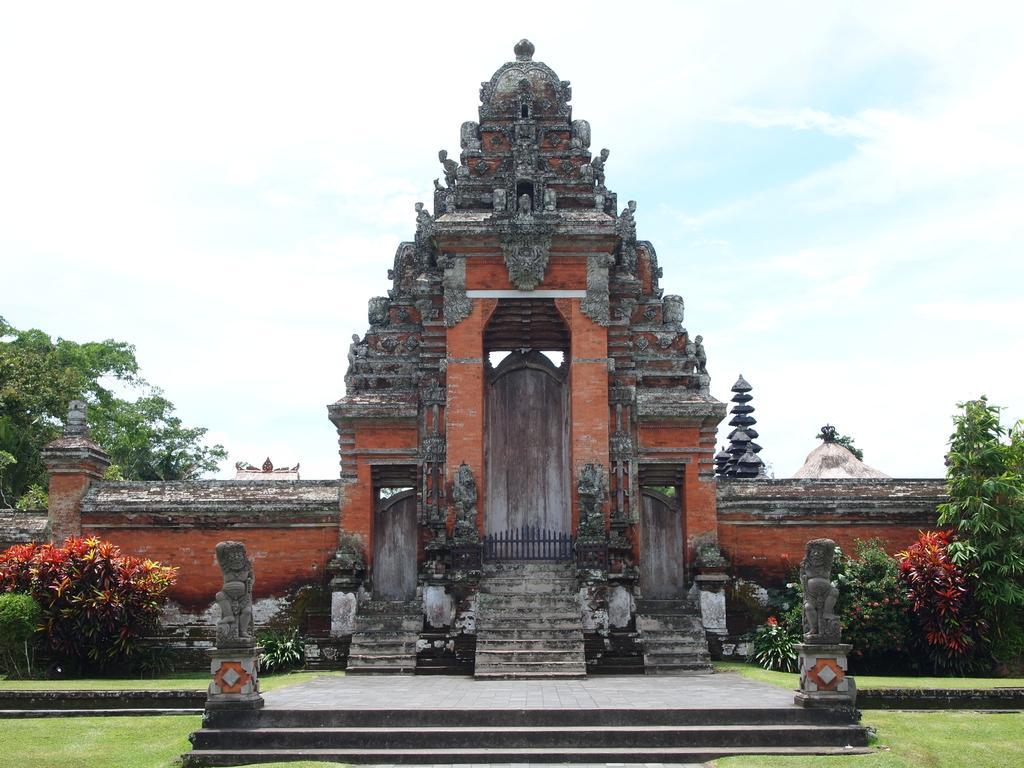In one or two sentences, can you explain what this image depicts? Here we can see the entrance doors of a temple,plants,wall,steps and grass at the bottom. In the background there are trees and clouds in the sky. 